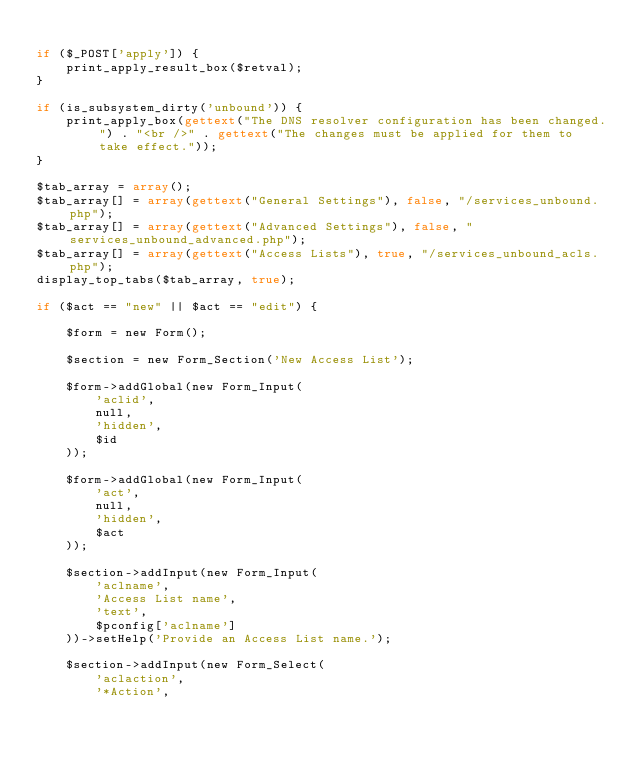Convert code to text. <code><loc_0><loc_0><loc_500><loc_500><_PHP_>
if ($_POST['apply']) {
	print_apply_result_box($retval);
}

if (is_subsystem_dirty('unbound')) {
	print_apply_box(gettext("The DNS resolver configuration has been changed.") . "<br />" . gettext("The changes must be applied for them to take effect."));
}

$tab_array = array();
$tab_array[] = array(gettext("General Settings"), false, "/services_unbound.php");
$tab_array[] = array(gettext("Advanced Settings"), false, "services_unbound_advanced.php");
$tab_array[] = array(gettext("Access Lists"), true, "/services_unbound_acls.php");
display_top_tabs($tab_array, true);

if ($act == "new" || $act == "edit") {

	$form = new Form();

	$section = new Form_Section('New Access List');

	$form->addGlobal(new Form_Input(
		'aclid',
		null,
		'hidden',
		$id
	));

	$form->addGlobal(new Form_Input(
		'act',
		null,
		'hidden',
		$act
	));

	$section->addInput(new Form_Input(
		'aclname',
		'Access List name',
		'text',
		$pconfig['aclname']
	))->setHelp('Provide an Access List name.');

	$section->addInput(new Form_Select(
		'aclaction',
		'*Action',</code> 